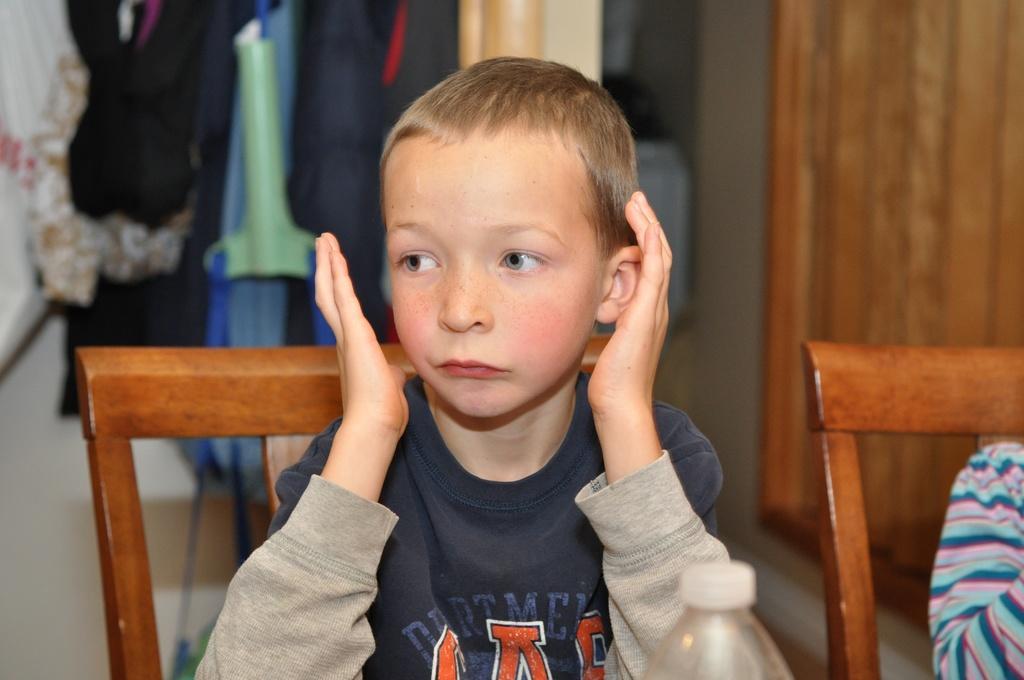Please provide a concise description of this image. This Picture describe about the small boy wearing blue t- shirt is sitting on the chair keeping both the hands near the ears, behind we can see a woman standing and on the right side we can see the wooden panel. 